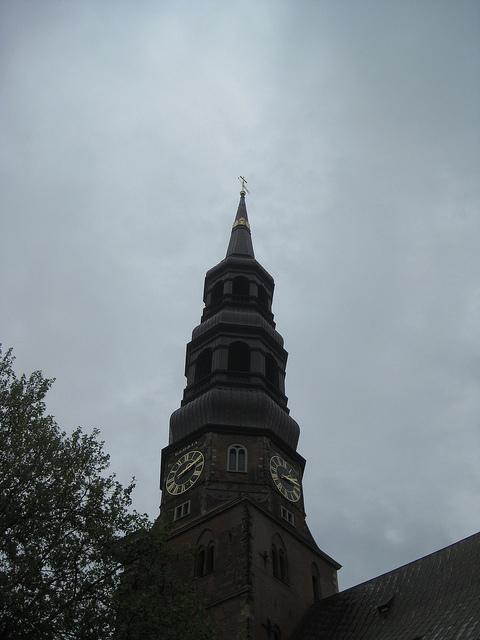How many spots does the giraffe on the left have exposed on its neck?
Give a very brief answer. 0. 